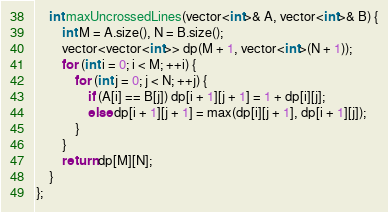Convert code to text. <code><loc_0><loc_0><loc_500><loc_500><_C++_>    int maxUncrossedLines(vector<int>& A, vector<int>& B) {
        int M = A.size(), N = B.size();
        vector<vector<int>> dp(M + 1, vector<int>(N + 1));
        for (int i = 0; i < M; ++i) {
            for (int j = 0; j < N; ++j) {
                if (A[i] == B[j]) dp[i + 1][j + 1] = 1 + dp[i][j];
                else dp[i + 1][j + 1] = max(dp[i][j + 1], dp[i + 1][j]);
            }
        }
        return dp[M][N];
    }
};</code> 